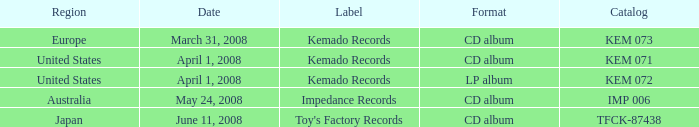Which brand encompasses a united states territory and an lp album format? Kemado Records. Could you parse the entire table as a dict? {'header': ['Region', 'Date', 'Label', 'Format', 'Catalog'], 'rows': [['Europe', 'March 31, 2008', 'Kemado Records', 'CD album', 'KEM 073'], ['United States', 'April 1, 2008', 'Kemado Records', 'CD album', 'KEM 071'], ['United States', 'April 1, 2008', 'Kemado Records', 'LP album', 'KEM 072'], ['Australia', 'May 24, 2008', 'Impedance Records', 'CD album', 'IMP 006'], ['Japan', 'June 11, 2008', "Toy's Factory Records", 'CD album', 'TFCK-87438']]} 